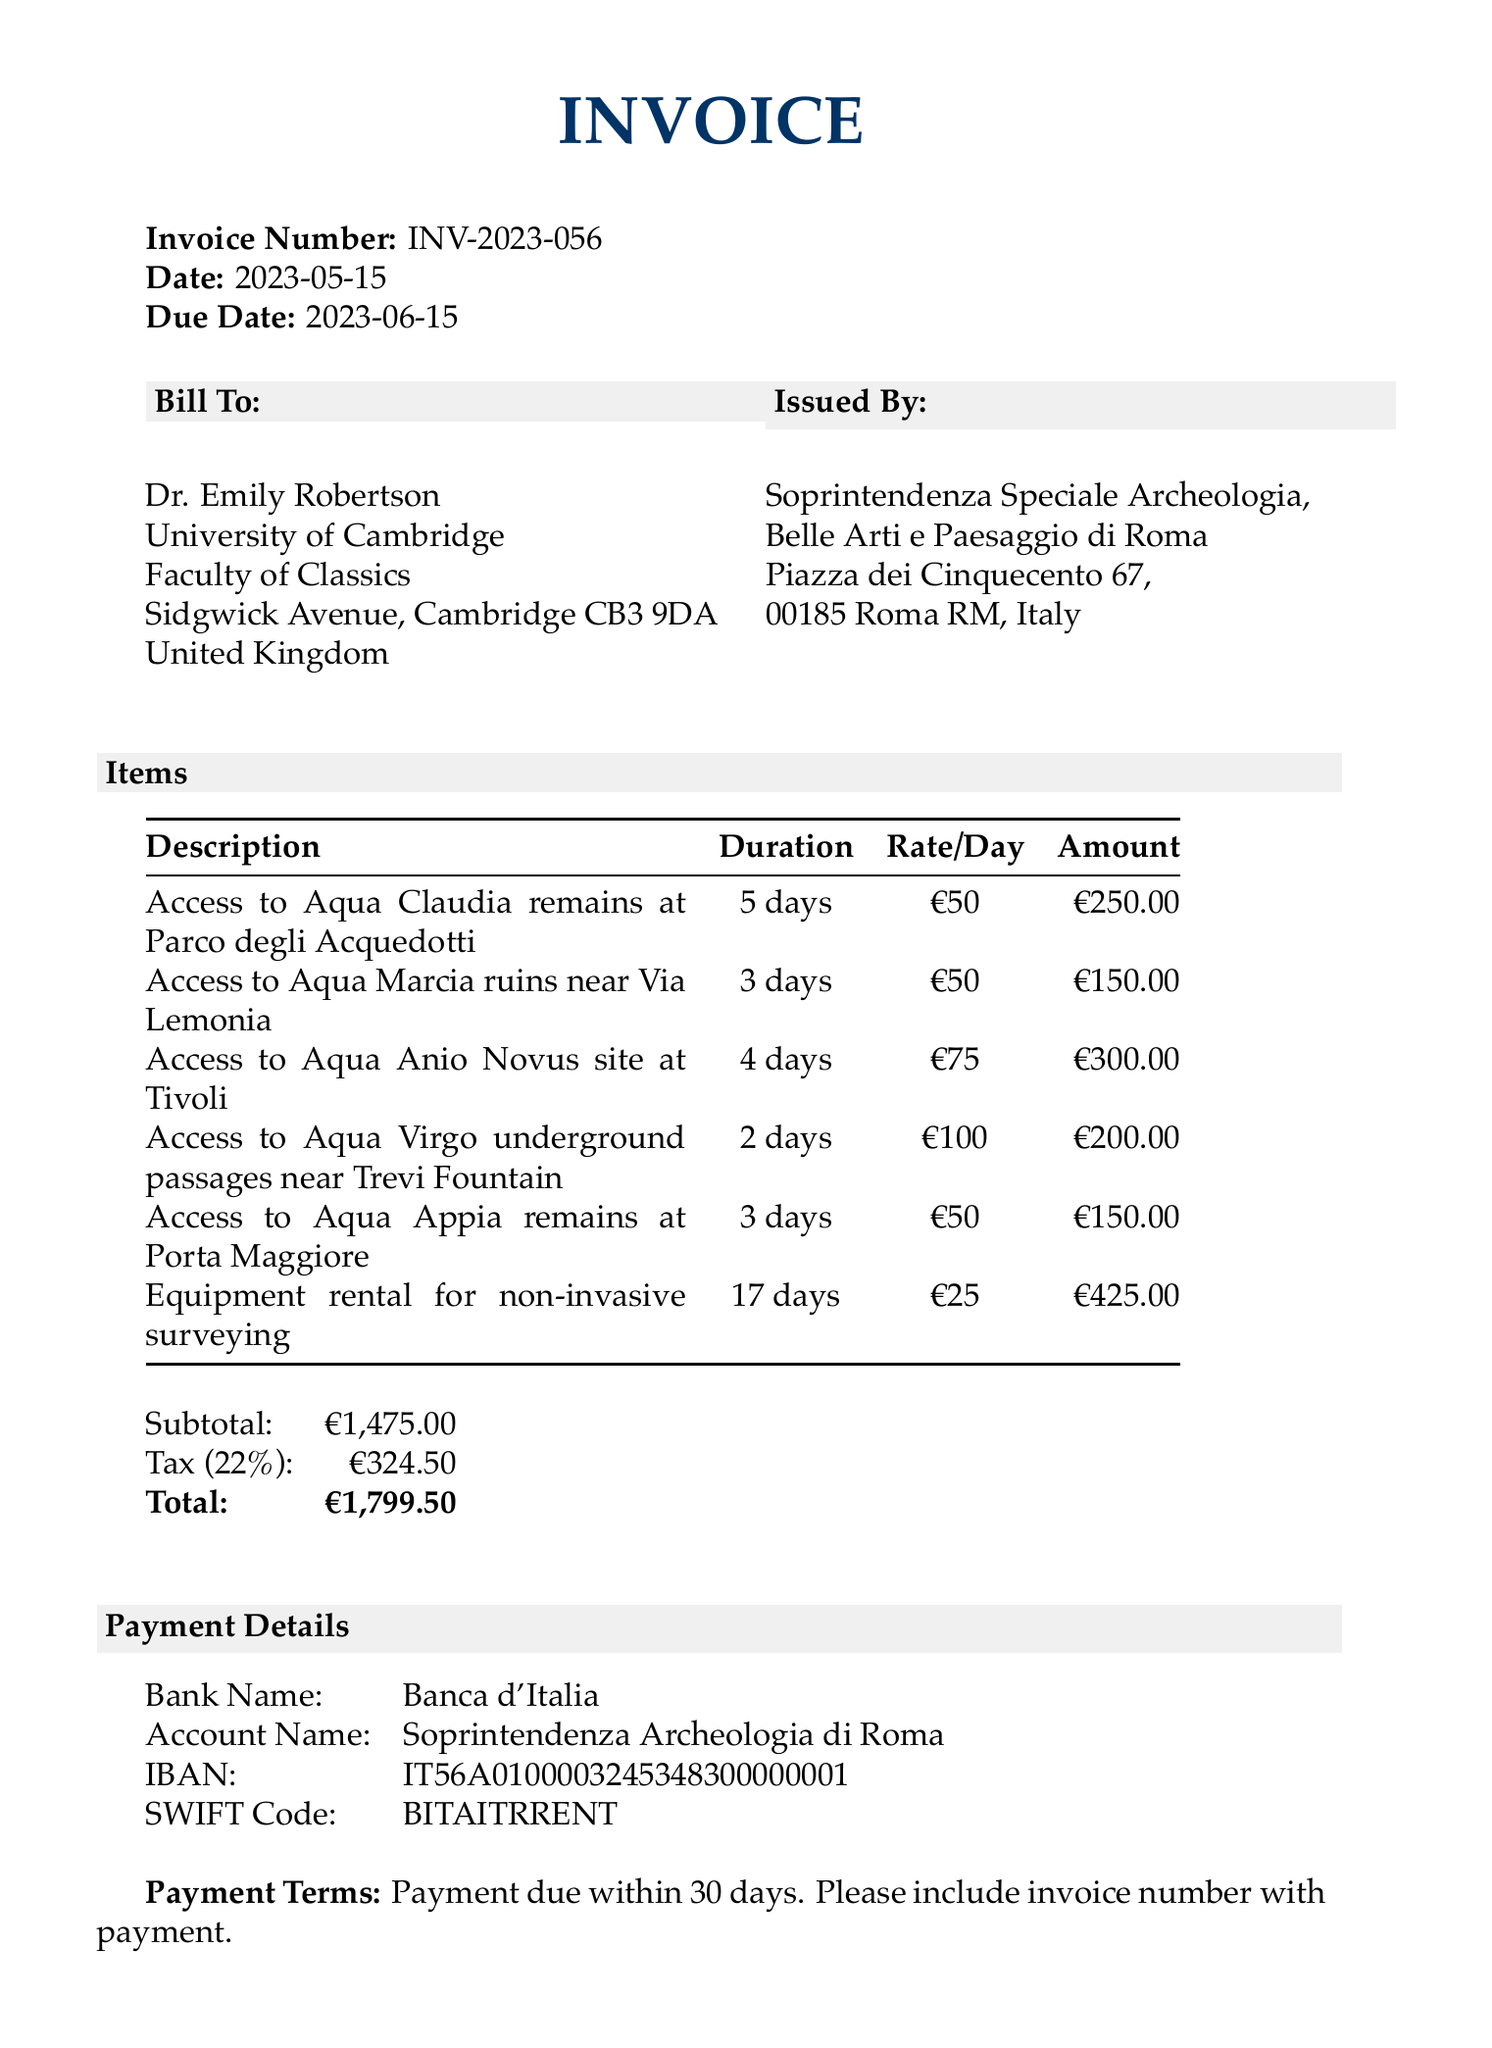What is the invoice number? The invoice number is prominently listed at the top of the document.
Answer: INV-2023-056 Who is the invoice billed to? The recipient of the invoice is clearly stated in the "Bill To" section.
Answer: Dr. Emily Robertson What is the due date for payment? The due date is specified below the invoice date in the document.
Answer: 2023-06-15 How much is the tax amount? The tax amount is provided in the financial summary at the bottom of the invoice.
Answer: €324.50 What is the total amount due? The total amount due is highlighted in bold in the invoice summary.
Answer: €1,799.50 Which location had the highest access fee? The access fee details for each location are provided, allowing for a comparison of amounts.
Answer: Aqua Anio Novus site at Tivoli How many days of access were purchased for the Aqua Virgo site? The duration of access for each item is listed in the respective item section.
Answer: 2 days What equipment was rented according to the invoice? The items listed include equipment rental which is explicitly detailed.
Answer: Equipment rental for non-invasive surveying What payment method is specified? Information about the payment method is included under the payment details section.
Answer: Bank transfer 